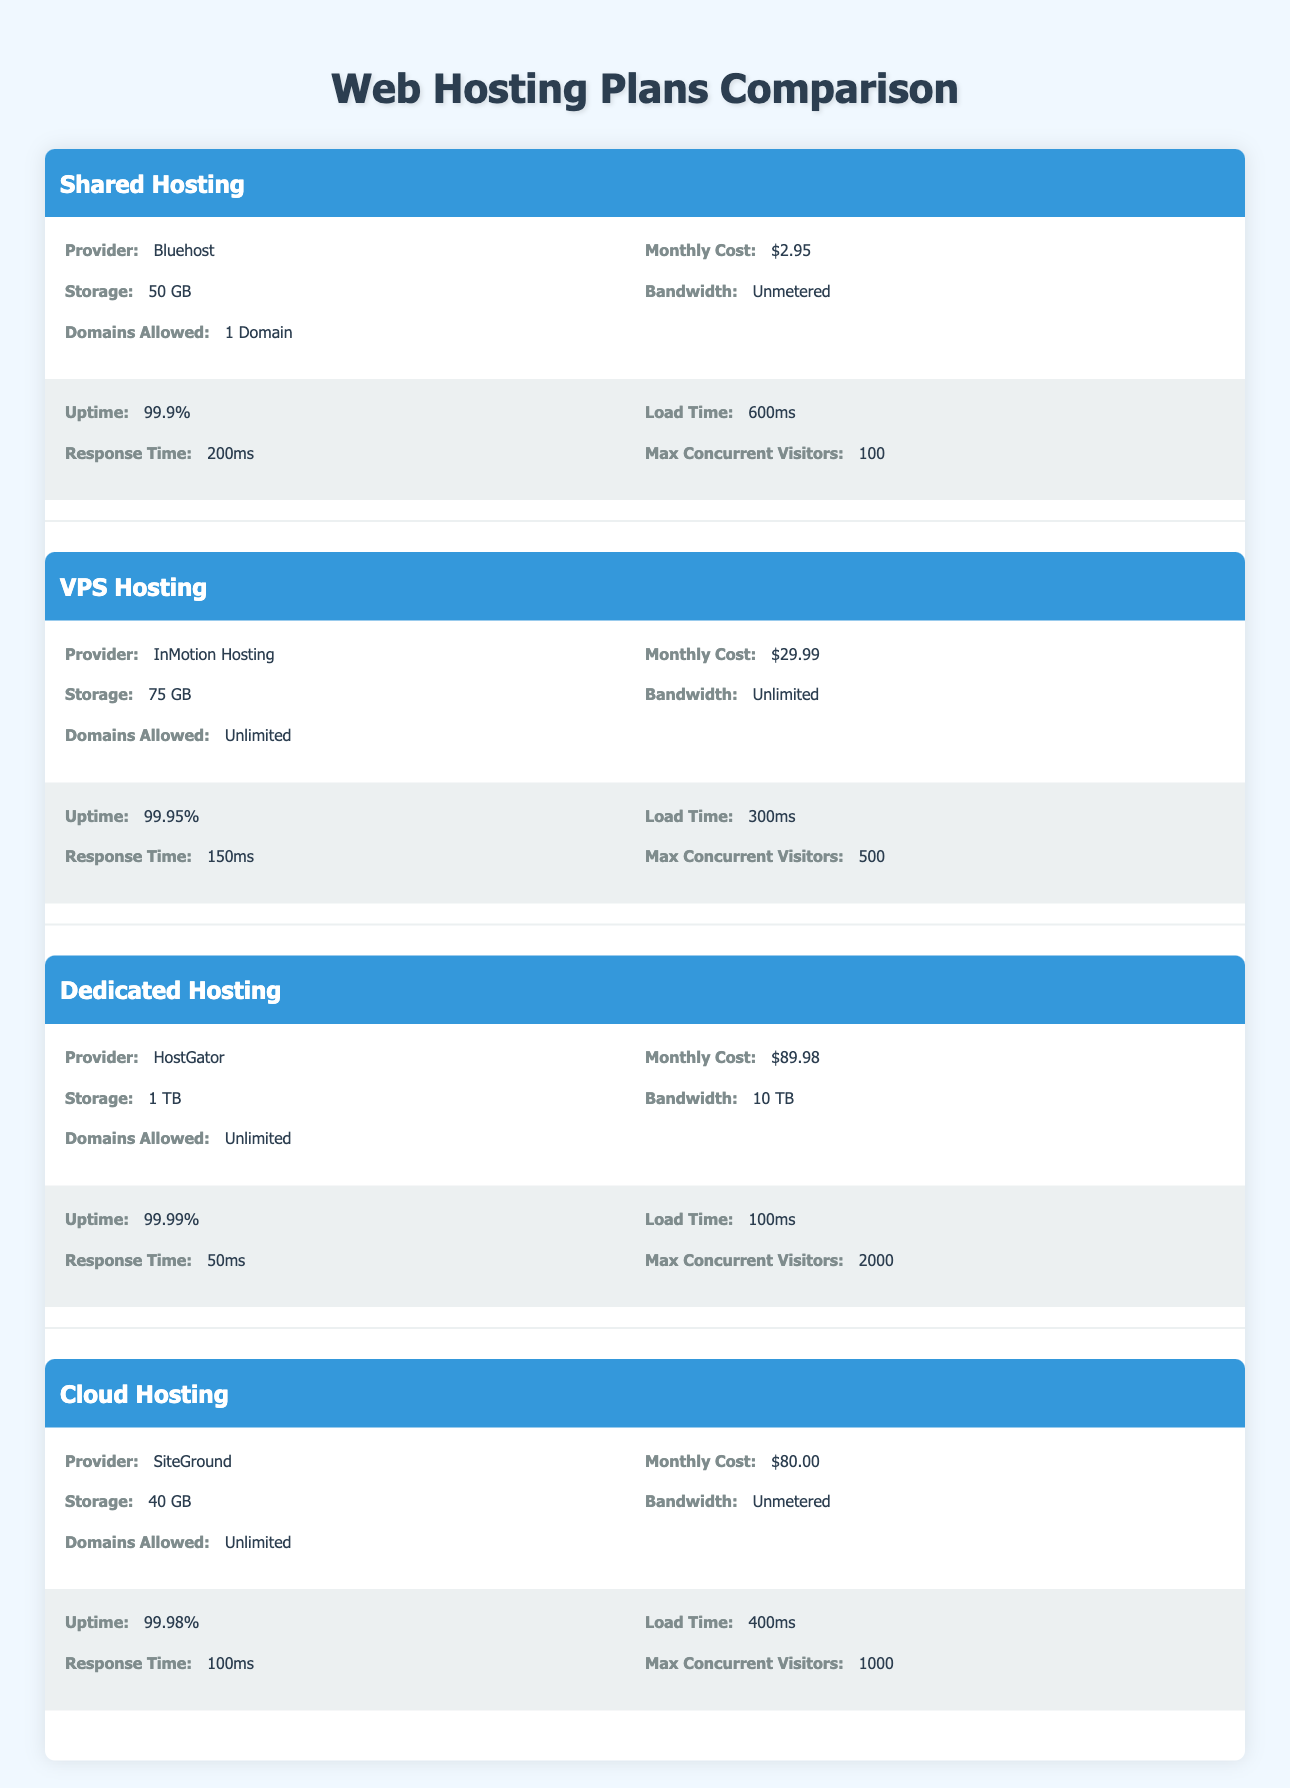What is the monthly cost of VPS Hosting? VPS Hosting's monthly cost is specifically listed in the table as "$29.99."
Answer: $29.99 Which hosting plan has the highest uptime? The highest uptime in the table is listed under Dedicated Hosting at "99.99%."
Answer: 99.99% What is the difference in load time between Shared Hosting and Dedicated Hosting? Shared Hosting has a load time of "600ms," while Dedicated Hosting has a load time of "100ms." The difference is 600ms - 100ms = 500ms.
Answer: 500ms Is the bandwidth for Shared Hosting unmetered, and how does it compare to VPS Hosting? Yes, Shared Hosting's bandwidth is "Unmetered," while VPS Hosting has "Unlimited" bandwidth. Both terms imply no specific limits, so they are effectively the same in this context.
Answer: Yes How many max concurrent visitors can the Dedicated Hosting plan support compared to Shared Hosting? Dedicated Hosting supports "2000" max concurrent visitors, while Shared Hosting supports "100" max concurrent visitors. The comparison shows that Dedicated Hosting can handle significantly more users, specifically 2000 - 100 = 1900 more.
Answer: 1900 